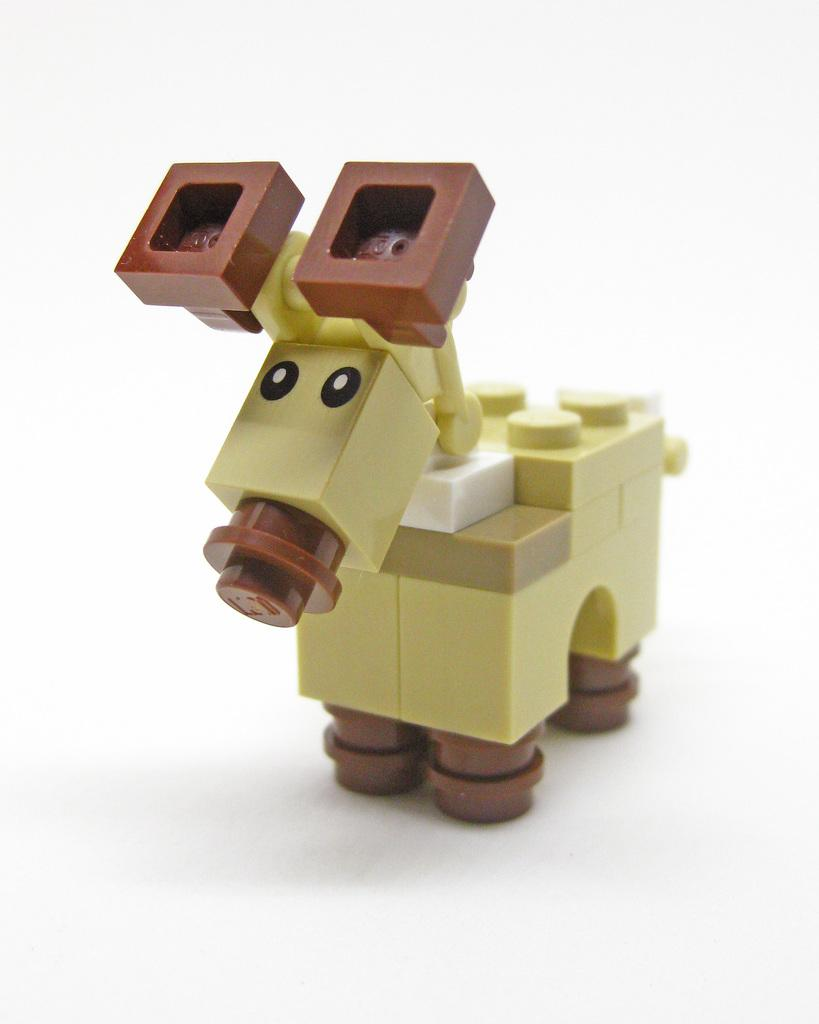What is the main object in the image? There is a toy in the image. What type of toy is it? The toy has blocks. What is the color of the surface the toy and blocks are on? The toy and blocks are on a white surface. What type of face can be seen on the toy in the image? There is no face present on the toy in the image. What team is associated with the toy in the image? There is no team associated with the toy in the image. 